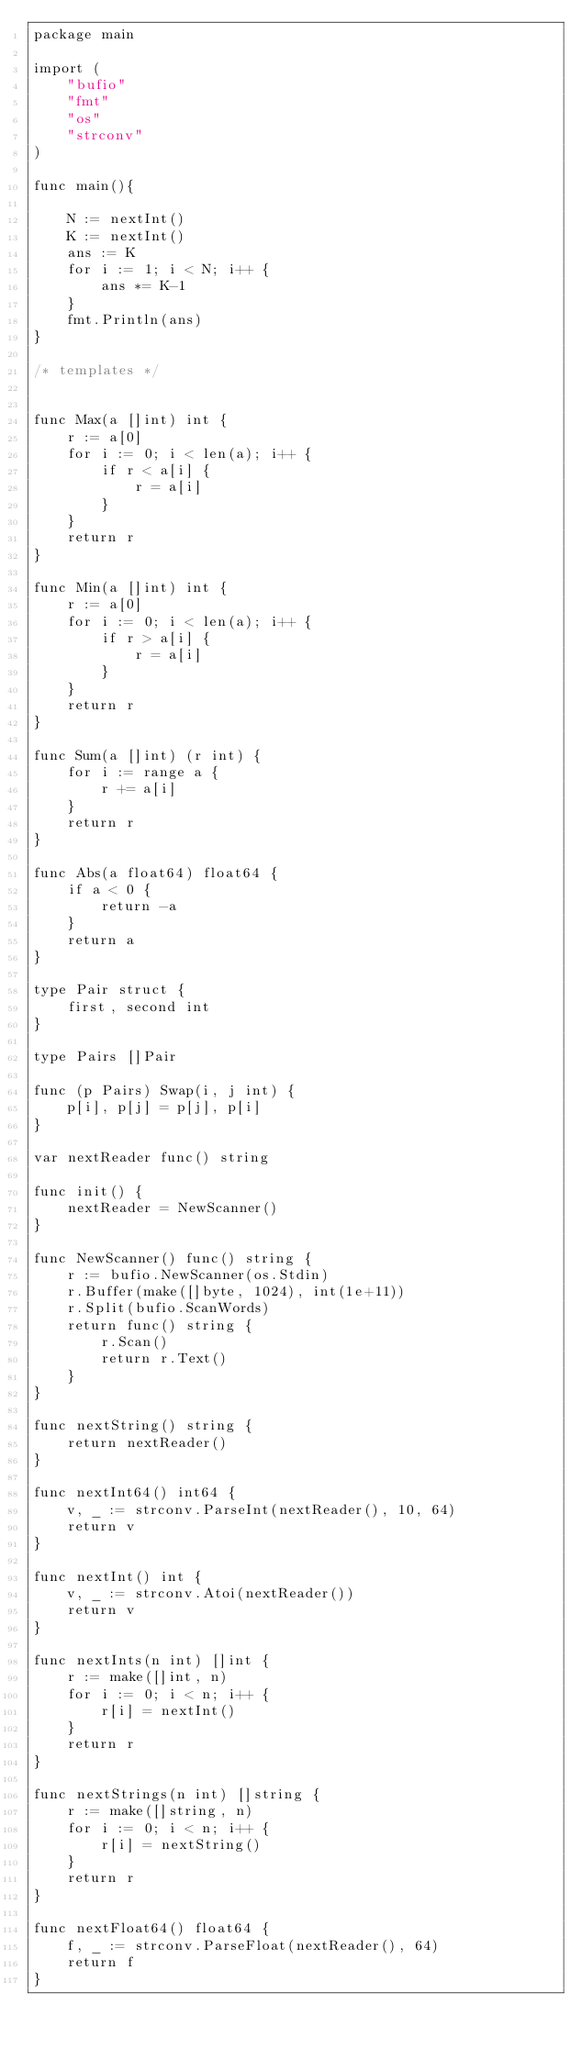Convert code to text. <code><loc_0><loc_0><loc_500><loc_500><_Go_>package main
 
import (
    "bufio"
    "fmt"
    "os"
    "strconv"
)

func main(){
    
    N := nextInt()
    K := nextInt()
    ans := K
    for i := 1; i < N; i++ {
        ans *= K-1
    }
    fmt.Println(ans)
}

/* templates */


func Max(a []int) int {
    r := a[0]
    for i := 0; i < len(a); i++ {
        if r < a[i] {
            r = a[i]
        }
    }
    return r
}
 
func Min(a []int) int {
    r := a[0]
    for i := 0; i < len(a); i++ {
        if r > a[i] {
            r = a[i]
        }
    }
    return r
}
 
func Sum(a []int) (r int) {
    for i := range a {
        r += a[i]
    }
    return r
}
 
func Abs(a float64) float64 {
    if a < 0 {
        return -a
    }
    return a
}
 
type Pair struct {
    first, second int
}
 
type Pairs []Pair
  
func (p Pairs) Swap(i, j int) {
    p[i], p[j] = p[j], p[i]
}
 
var nextReader func() string
 
func init() {
    nextReader = NewScanner()
}
 
func NewScanner() func() string {
    r := bufio.NewScanner(os.Stdin)
    r.Buffer(make([]byte, 1024), int(1e+11))
    r.Split(bufio.ScanWords)
    return func() string {
        r.Scan()
        return r.Text()
    }
}

func nextString() string {
    return nextReader()
}
 
func nextInt64() int64 {
    v, _ := strconv.ParseInt(nextReader(), 10, 64)
    return v
}
 
func nextInt() int {
    v, _ := strconv.Atoi(nextReader())
    return v
}
 
func nextInts(n int) []int {
    r := make([]int, n)
    for i := 0; i < n; i++ {
        r[i] = nextInt()
    }
    return r
}

func nextStrings(n int) []string {
    r := make([]string, n)
    for i := 0; i < n; i++ {
        r[i] = nextString()
    }
    return r
}

func nextFloat64() float64 {
    f, _ := strconv.ParseFloat(nextReader(), 64)
    return f
}
</code> 